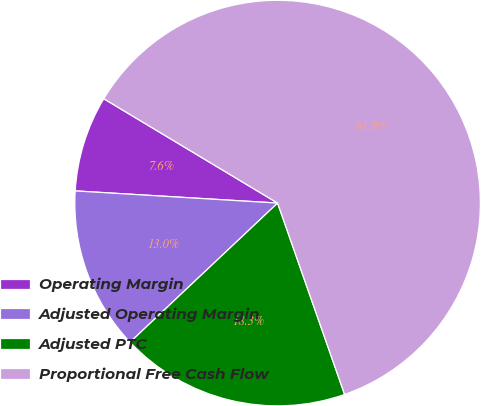Convert chart. <chart><loc_0><loc_0><loc_500><loc_500><pie_chart><fcel>Operating Margin<fcel>Adjusted Operating Margin<fcel>Adjusted PTC<fcel>Proportional Free Cash Flow<nl><fcel>7.65%<fcel>12.99%<fcel>18.33%<fcel>61.04%<nl></chart> 